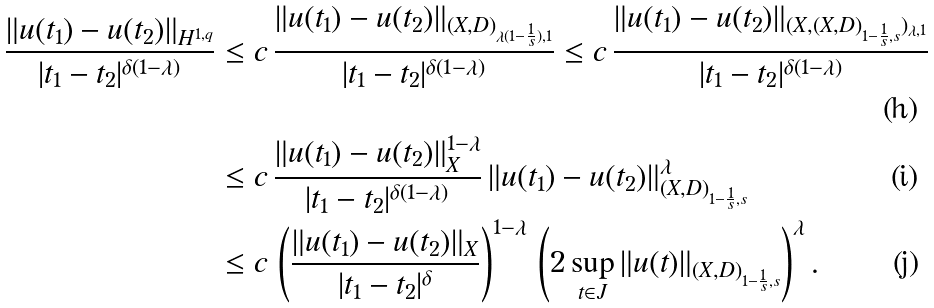Convert formula to latex. <formula><loc_0><loc_0><loc_500><loc_500>\frac { \| u ( t _ { 1 } ) - u ( t _ { 2 } ) \| _ { H ^ { 1 , q } } } { | t _ { 1 } - t _ { 2 } | ^ { \delta ( 1 - \lambda ) } } & \leq c \, \frac { \| u ( t _ { 1 } ) - u ( t _ { 2 } ) \| _ { ( X , D ) _ { \lambda ( 1 - \frac { 1 } { s } ) , 1 } } } { | t _ { 1 } - t _ { 2 } | ^ { \delta ( 1 - \lambda ) } } \leq c \, \frac { \| u ( t _ { 1 } ) - u ( t _ { 2 } ) \| _ { ( X , ( X , D ) _ { 1 - \frac { 1 } { s } , s } ) _ { \lambda , 1 } } } { | t _ { 1 } - t _ { 2 } | ^ { \delta ( 1 - \lambda ) } } \\ & \leq c \, \frac { \| u ( t _ { 1 } ) - u ( t _ { 2 } ) \| ^ { 1 - \lambda } _ { X } } { | t _ { 1 } - t _ { 2 } | ^ { \delta ( 1 - \lambda ) } } \, \| u ( t _ { 1 } ) - u ( t _ { 2 } ) \| ^ { \lambda } _ { ( X , D ) _ { 1 - \frac { 1 } { s } , s } } \\ & \leq c \, \left ( \frac { \| u ( t _ { 1 } ) - u ( t _ { 2 } ) \| _ { X } } { | t _ { 1 } - t _ { 2 } | ^ { \delta } } \right ) ^ { 1 - \lambda } \, \left ( 2 \sup _ { t \in J } \| u ( t ) \| _ { ( X , D ) _ { 1 - \frac { 1 } { s } , s } } \right ) ^ { \lambda } .</formula> 